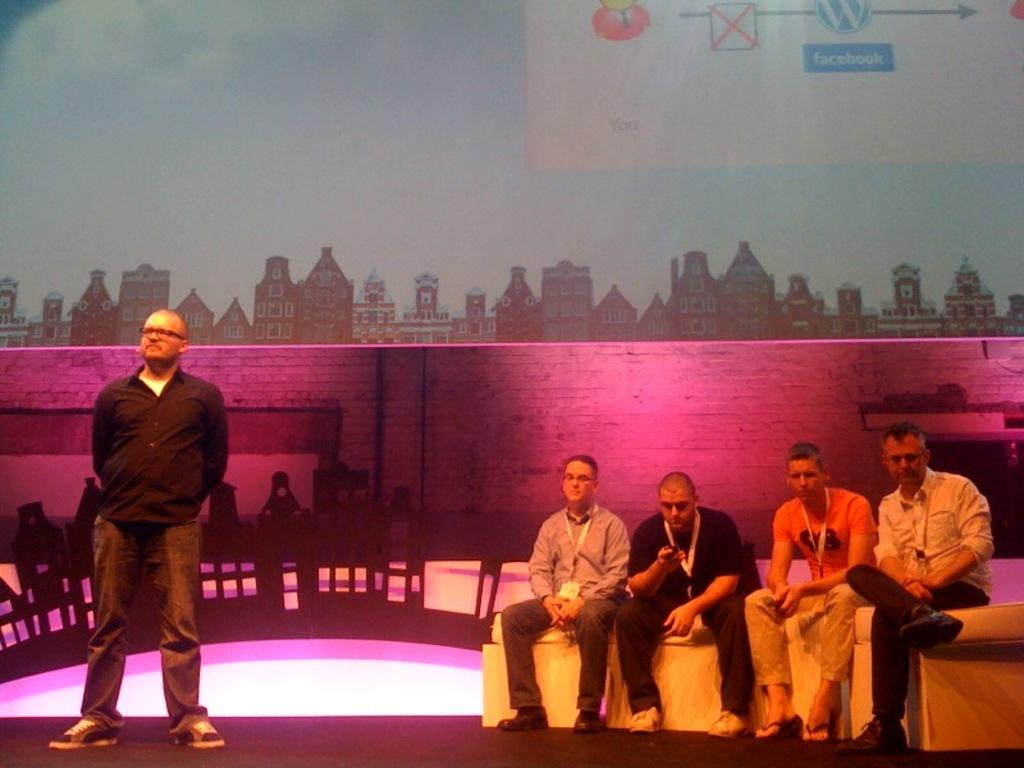What are the people in the image doing? There are people sitting on a couch in the image. Are there any other people in the image besides those sitting on the couch? Yes, there is a person standing in the image. What can be seen in the background of the image? There is a wall visible in the background of the image, and there is a banner on the wall. How would you describe the lighting in the image? The lighting in the image includes pink and yellow colors. How many fingers does the clock have in the image? There is no clock present in the image, so it is not possible to determine the number of fingers on the clock. 